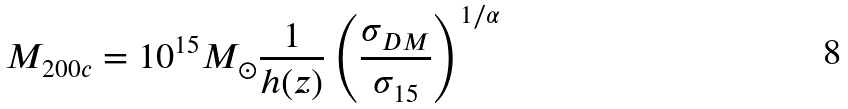Convert formula to latex. <formula><loc_0><loc_0><loc_500><loc_500>M _ { 2 0 0 c } = 1 0 ^ { 1 5 } M _ { \odot } \frac { 1 } { h ( z ) } \left ( \frac { \sigma _ { D M } } { \sigma _ { 1 5 } } \right ) ^ { 1 / \alpha }</formula> 